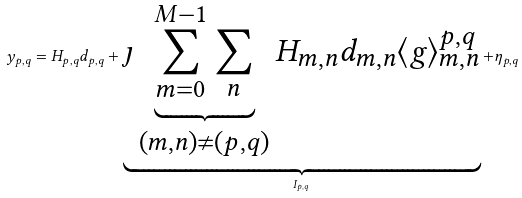<formula> <loc_0><loc_0><loc_500><loc_500>y _ { p , q } = H _ { p , q } d _ { p , q } + \underbrace { \jmath \underbrace { \sum _ { m = 0 } ^ { M - 1 } \sum _ { n } } _ { ( m , n ) \neq ( p , q ) } H _ { m , n } d _ { m , n } \langle g \rangle _ { m , n } ^ { p , q } } _ { I _ { p , q } } + \eta _ { p , q }</formula> 